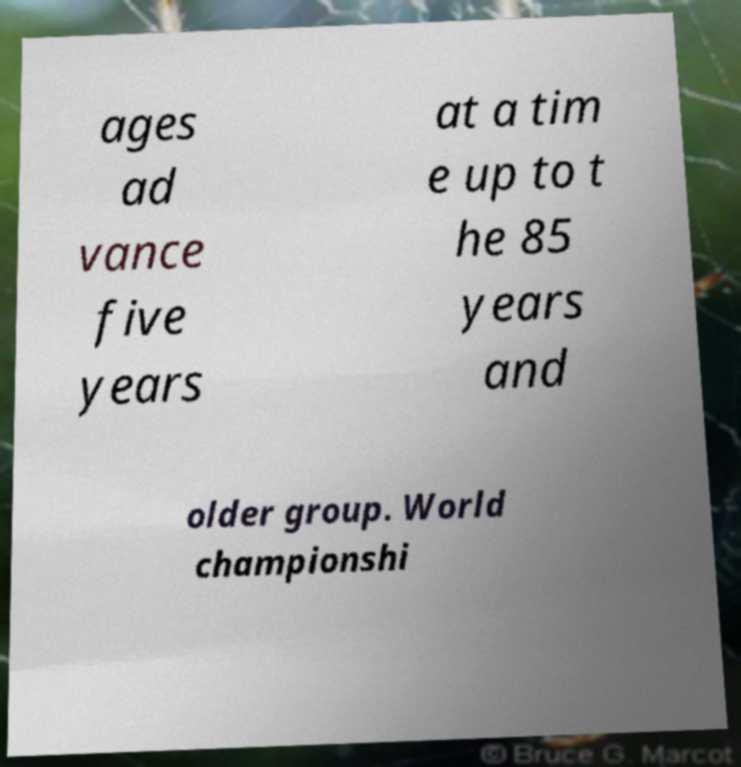Could you assist in decoding the text presented in this image and type it out clearly? ages ad vance five years at a tim e up to t he 85 years and older group. World championshi 